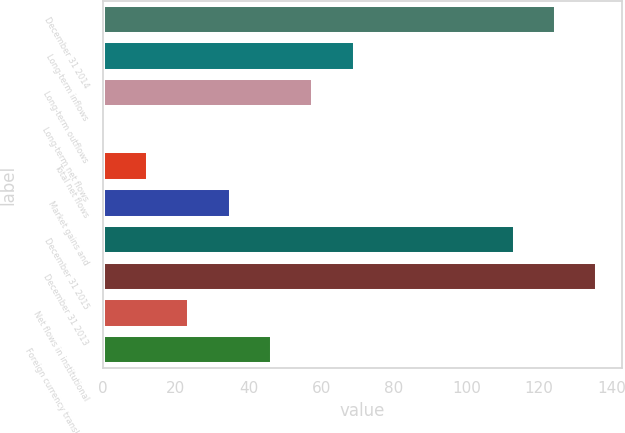Convert chart. <chart><loc_0><loc_0><loc_500><loc_500><bar_chart><fcel>December 31 2014<fcel>Long-term inflows<fcel>Long-term outflows<fcel>Long-term net flows<fcel>Total net flows<fcel>Market gains and<fcel>December 31 2015<fcel>December 31 2013<fcel>Net flows in institutional<fcel>Foreign currency translation<nl><fcel>124.68<fcel>69.24<fcel>57.85<fcel>0.9<fcel>12.29<fcel>35.07<fcel>113.29<fcel>136.07<fcel>23.68<fcel>46.46<nl></chart> 